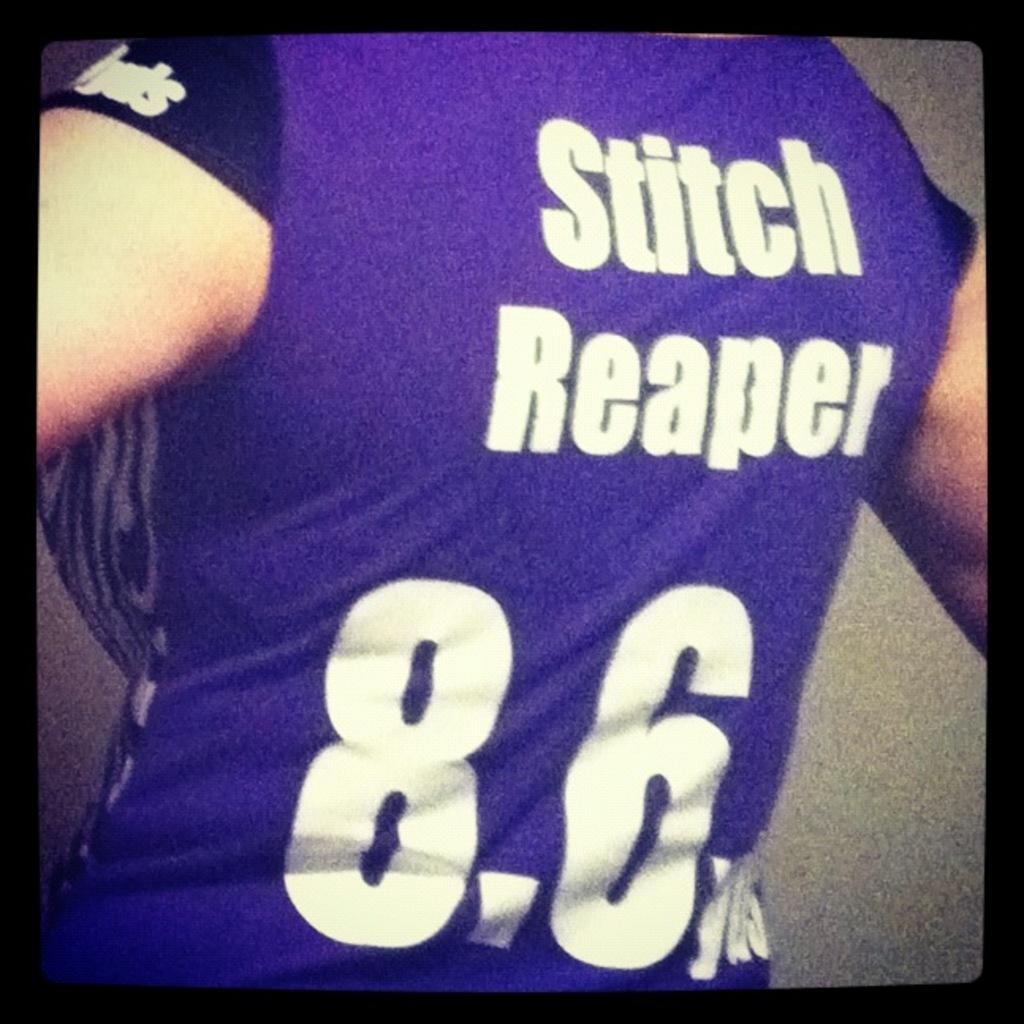<image>
Relay a brief, clear account of the picture shown. A close up of the back of top which bears the words Stitch Reaper and the numbers 8.6 